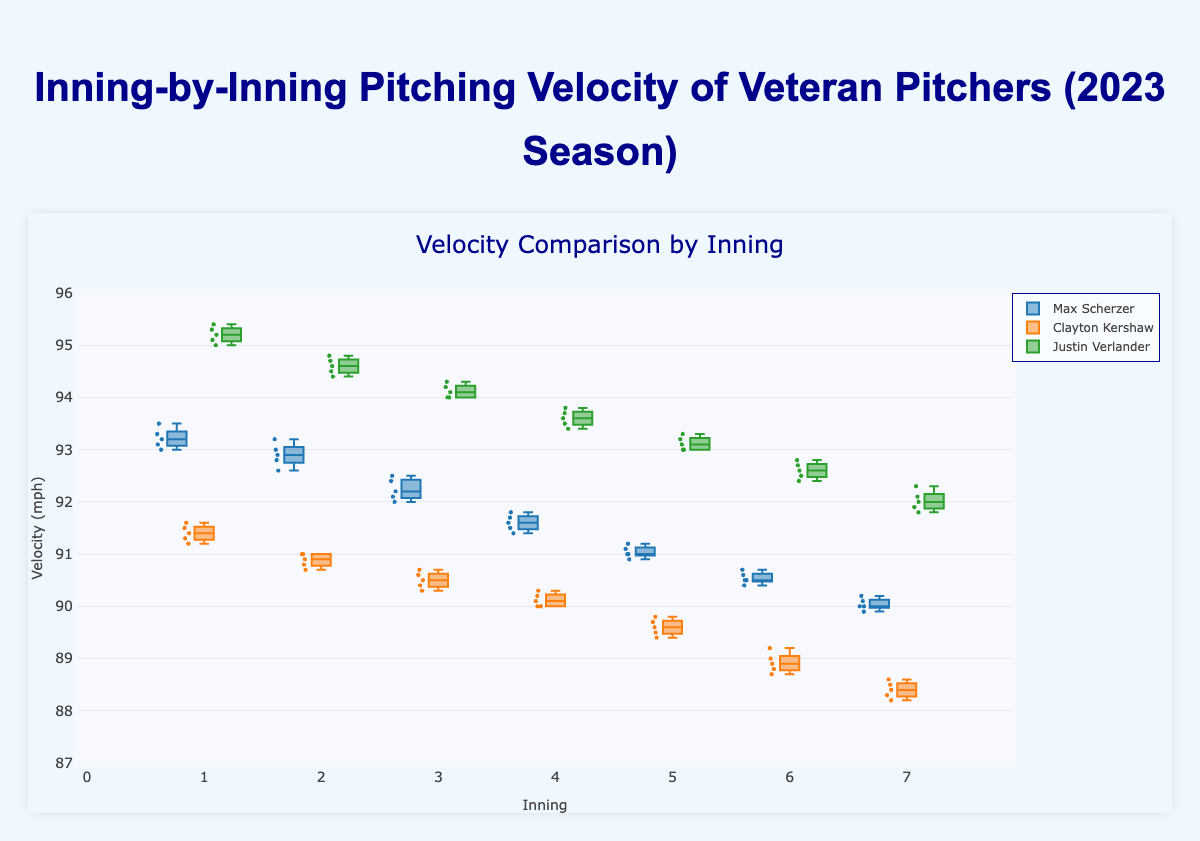What is the title of the figure? The title is displayed at the top of the figure in larger font size. It helps to quickly understand the topic of the plot.
Answer: Inning-by-Inning Pitching Velocity of Veteran Pitchers (2023 Season) What does the x-axis represent? The x-axis represents the different innings, labeled from 1 to 7, indicating the various stages of a baseball game.
Answer: Innings Who has the highest average velocity in the first inning? To find this, look at the median lines inside the boxes for the first inning for each pitcher. The pitcher with the highest median line has the highest average velocity.
Answer: Justin Verlander How does Max Scherzer's velocity change from the first inning to the seventh inning? This requires observing the median lines of Max Scherzer's data from the first inning to the seventh inning. Specifically, identify the drop in medians across the innings.
Answer: Decreases Which pitcher shows the most noticeable decline in velocity from inning 1 to inning 7? Compare the medians for all pitchers from inning 1 to inning 7. The pitcher with the largest difference shows the most noticeable decline.
Answer: Clayton Kershaw Which inning has the lowest median velocity for Justin Verlander? Observe the median line inside the boxes for each inning for Justin Verlander and identify the inning with the lowest median.
Answer: Inning 7 How do the median velocities in the seventh inning compare among the three pitchers? Compare the median lines of the seventh inning boxes for Max Scherzer, Clayton Kershaw, and Justin Verlander to see which has the highest and lowest values.
Answer: Verlander > Scherzer > Kershaw Do any pitchers maintain a consistent median velocity throughout the innings? Evaluate the consistency of the median lines within each box for all innings for each pitcher. Consistency means minimal change in median lines across innings.
Answer: No Which pitcher has the highest range of velocities in the first inning? To find this, check the distances between the top and bottom whiskers of the boxes for the first inning for each pitcher. The largest distance indicates the highest range.
Answer: Justin Verlander Does Justin Verlander have a higher velocity in the sixth inning compared to Max Scherzer? Compare the median lines of the sixth innings for both Justin Verlander and Max Scherzer.
Answer: Yes 